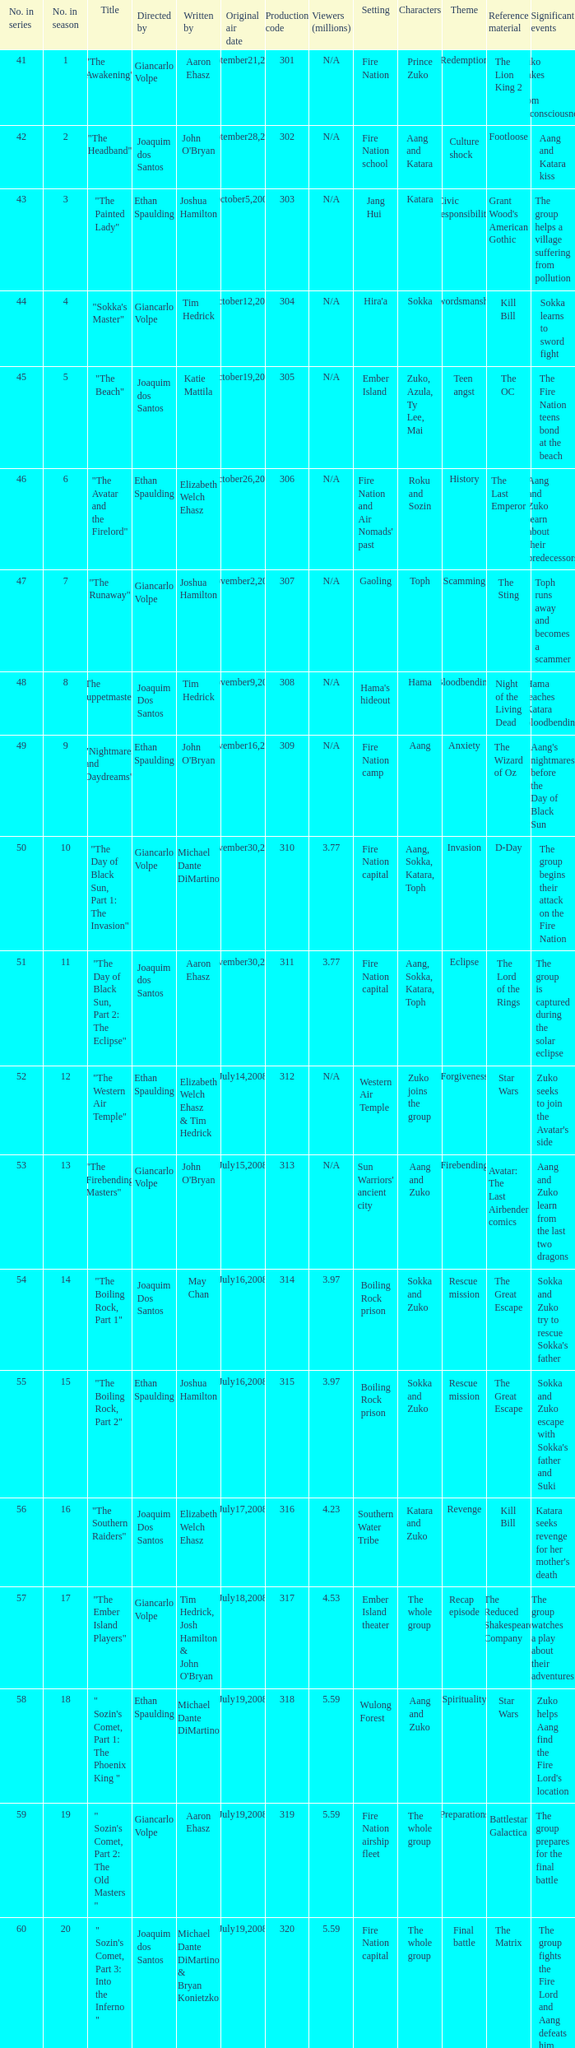How many viewers in millions for episode "sokka's master"? N/A. 